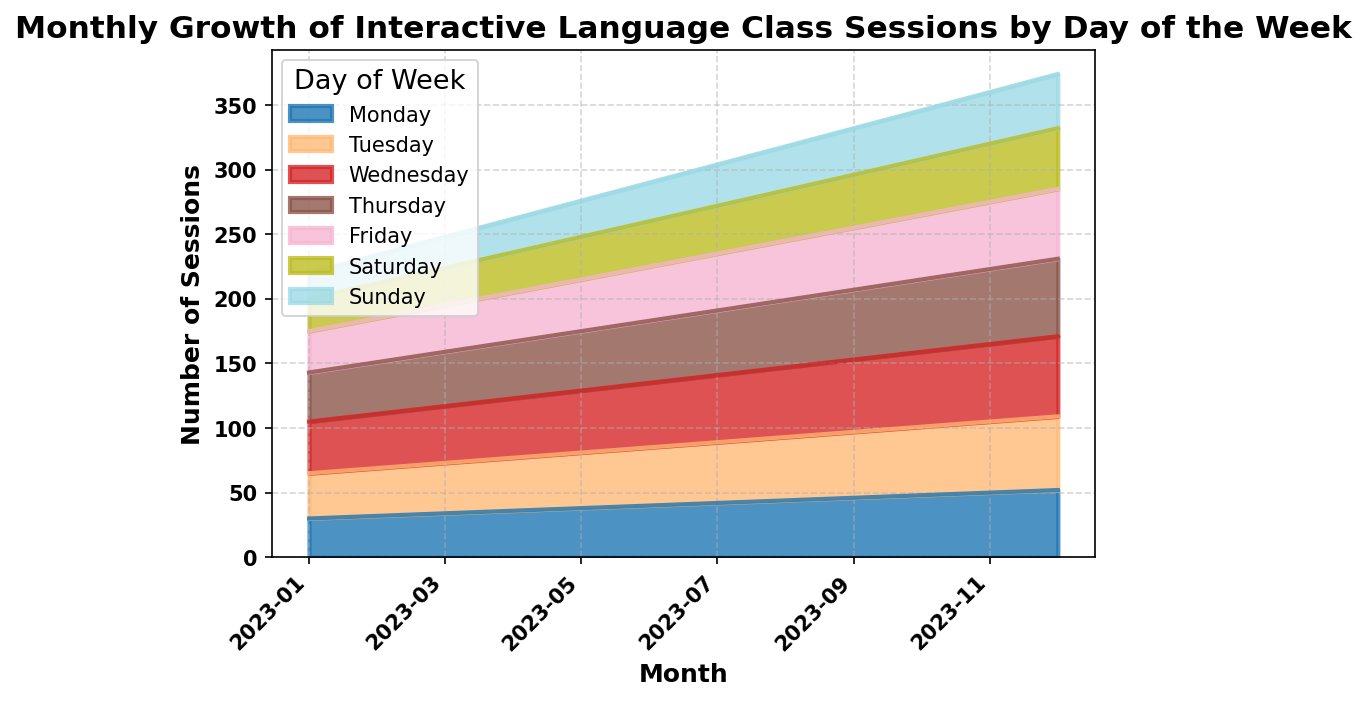What is the total number of interactive class sessions conducted in July 2023? Sum up the values of sessions for each day of the week in July: 42 (Monday) + 47 (Tuesday) + 52 (Wednesday) + 50 (Thursday) + 44 (Friday) + 37 (Saturday) + 32 (Sunday) = 304
Answer: 304 Which month had the highest number of interactive class sessions on Wednesdays? Check the value for Wednesdays in each month and find the maximum: January (40), February (42), March (44), April (46), May (48), June (50), July (52), August (54), September (56), October (58), November (60), December (62). The highest is in December with 62 sessions
Answer: December How did the number of sessions on Fridays change from January to December 2023? Look at and compare the number of sessions on Fridays in January (32) and December (54). The number increased by 54 - 32 = 22
Answer: Increased by 22 In which month did Sundays have the smallest number of interactive class sessions? Review the number of sessions on Sundays across all months: January (20), February (22), March (24), April (26), May (28), June (30), July (32), August (34), September (36), October (38), November (40), December (42). The smallest number is in January with 20
Answer: January By how much did the total number of interactive class sessions grow from the start to the end of the year? Calculate the total sessions in January (30+35+40+38+32+25+20 = 220) and December (52+57+62+60+54+47+42 = 374). The growth is 374 - 220 = 154
Answer: 154 Which day of the week consistently saw an increase in the number of interactive class sessions across all months? Observe the trend for each day of the week across all months. Each daily session count increases steadily from month to month. For example, Mondays: January (30) to December (52); likewise for other days
Answer: All days (Monday to Sunday) What is the average number of interactive class sessions held on Thursdays in the first quarter of 2023? Average the number of sessions on Thursdays in January (38), February (40), and March (42). (38 + 40 + 42) / 3 = 40
Answer: 40 How many more interactive class sessions were held on Saturdays in June compared to January 2023? Compare the values: June (35) - January (25) = 10
Answer: 10 Do Tuesdays or Fridays have a higher total number of interactive class sessions in December 2023? Compare the values: Tuesdays (57) and Fridays (54). 57 > 54, so Tuesdays have more sessions
Answer: Tuesdays How does the number of Wednesday sessions in September compare to October 2023? Compare the values: September (56) and October (58). 58 - 56 = 2, so October has 2 more sessions than September
Answer: October has 2 more sessions 